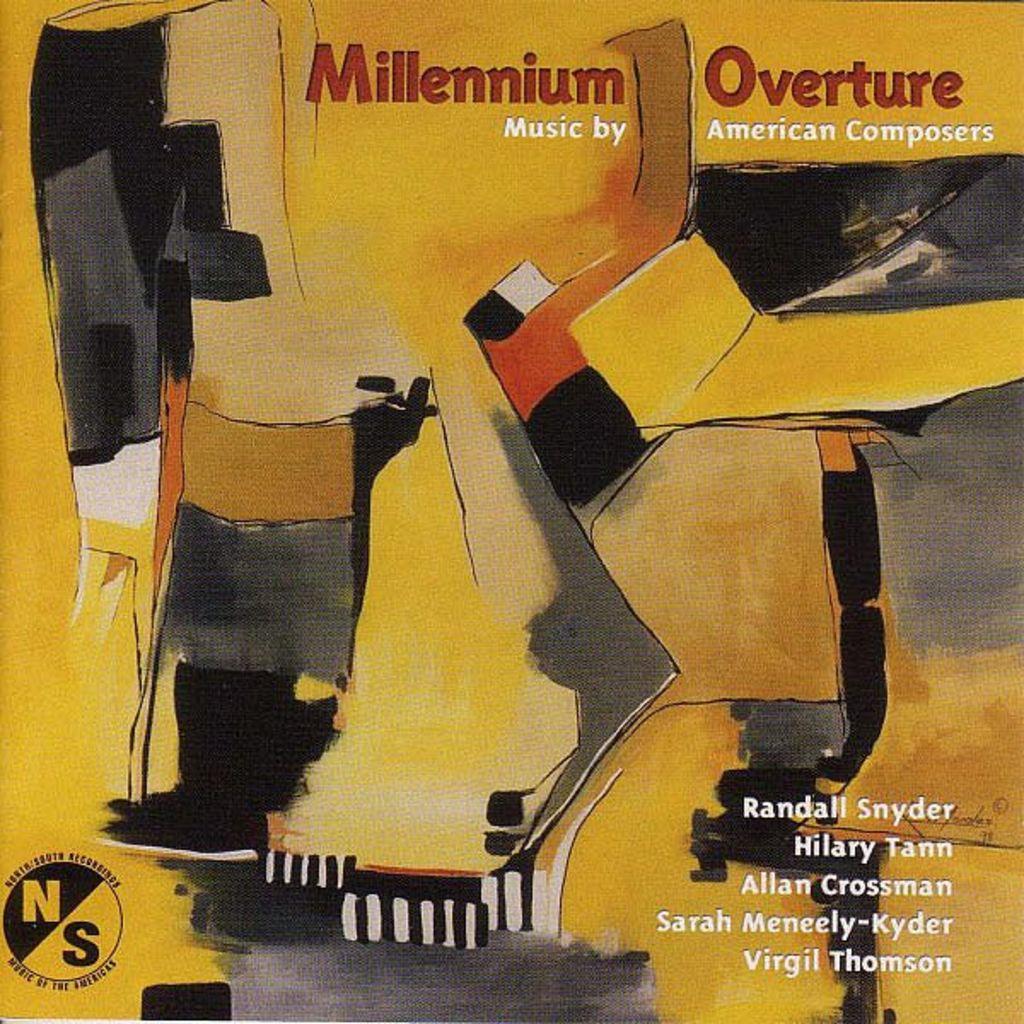What is the name of the album?
Keep it short and to the point. Millennium overture. Who is the music by?
Ensure brevity in your answer.  American composers. 